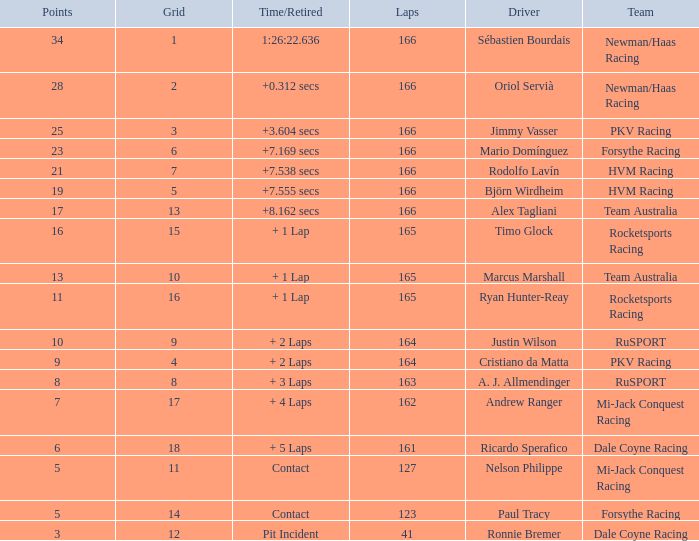What is the average points that the driver Ryan Hunter-Reay has? 11.0. 